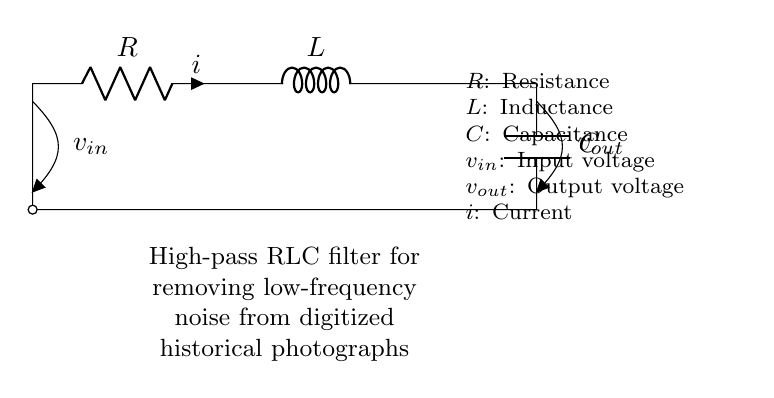What is the type of filter represented by this circuit? This circuit is a high-pass filter, as indicated in the labeling below the circuit diagram. High-pass filters allow high-frequency signals to pass while attenuating low-frequency signals, which is suitable for removing low-frequency noise.
Answer: High-pass filter What is the role of the resistor in this circuit? The resistor in this RLC circuit limits the current flow and affects the cutoff frequency of the filter. Its resistance influences how much the low-frequency signals are attenuated compared to high-frequency signals.
Answer: Limits current What are the inputs to this circuit? The input to the circuit is designated as v_in, which is marked clearly on the left side of the circuit diagram. This represents the voltage entering the high-pass filter.
Answer: v_in How many components are in this circuit? The circuit contains three fundamental components: a resistor, an inductor, and a capacitor. These are the essential parts that make up the RLC circuit.
Answer: Three What does v_out represent in this circuit? v_out represents the output voltage of the high-pass filter, indicating the voltage that appears across the capacitor at the output of the filter. This output is where the high-frequency signals will be present after filtering.
Answer: Output voltage What happens to low-frequency signals in this circuit? Low-frequency signals are attenuated or reduced in amplitude when they pass through this high-pass filter. The inductor and capacitor together work to block or minimize these low-frequency signals from reaching the output.
Answer: Attenuated 